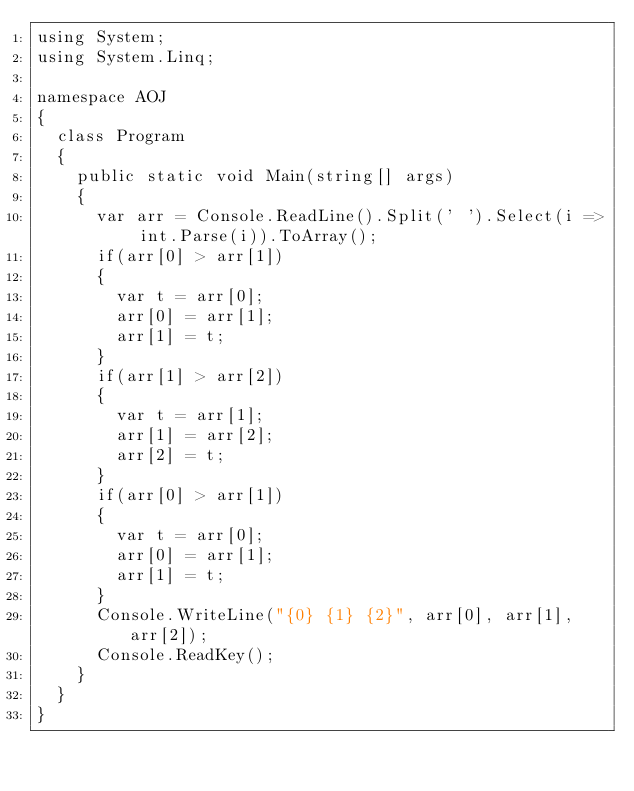<code> <loc_0><loc_0><loc_500><loc_500><_C#_>using System;
using System.Linq;

namespace AOJ
{
	class Program
	{
		public static void Main(string[] args)
		{
			var arr = Console.ReadLine().Split(' ').Select(i => int.Parse(i)).ToArray();
			if(arr[0] > arr[1])
			{
				var t = arr[0];
				arr[0] = arr[1];
				arr[1] = t;
			}
			if(arr[1] > arr[2])
			{
				var t = arr[1];
				arr[1] = arr[2];
				arr[2] = t;
			}
			if(arr[0] > arr[1])
			{
				var t = arr[0];
				arr[0] = arr[1];
				arr[1] = t;
			}
			Console.WriteLine("{0} {1} {2}", arr[0], arr[1], arr[2]);
			Console.ReadKey();
		}
	}
}</code> 